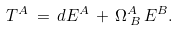<formula> <loc_0><loc_0><loc_500><loc_500>T ^ { A } \, = \, d E ^ { A } \, + \, \Omega _ { \, B } ^ { A } \, E ^ { B } .</formula> 